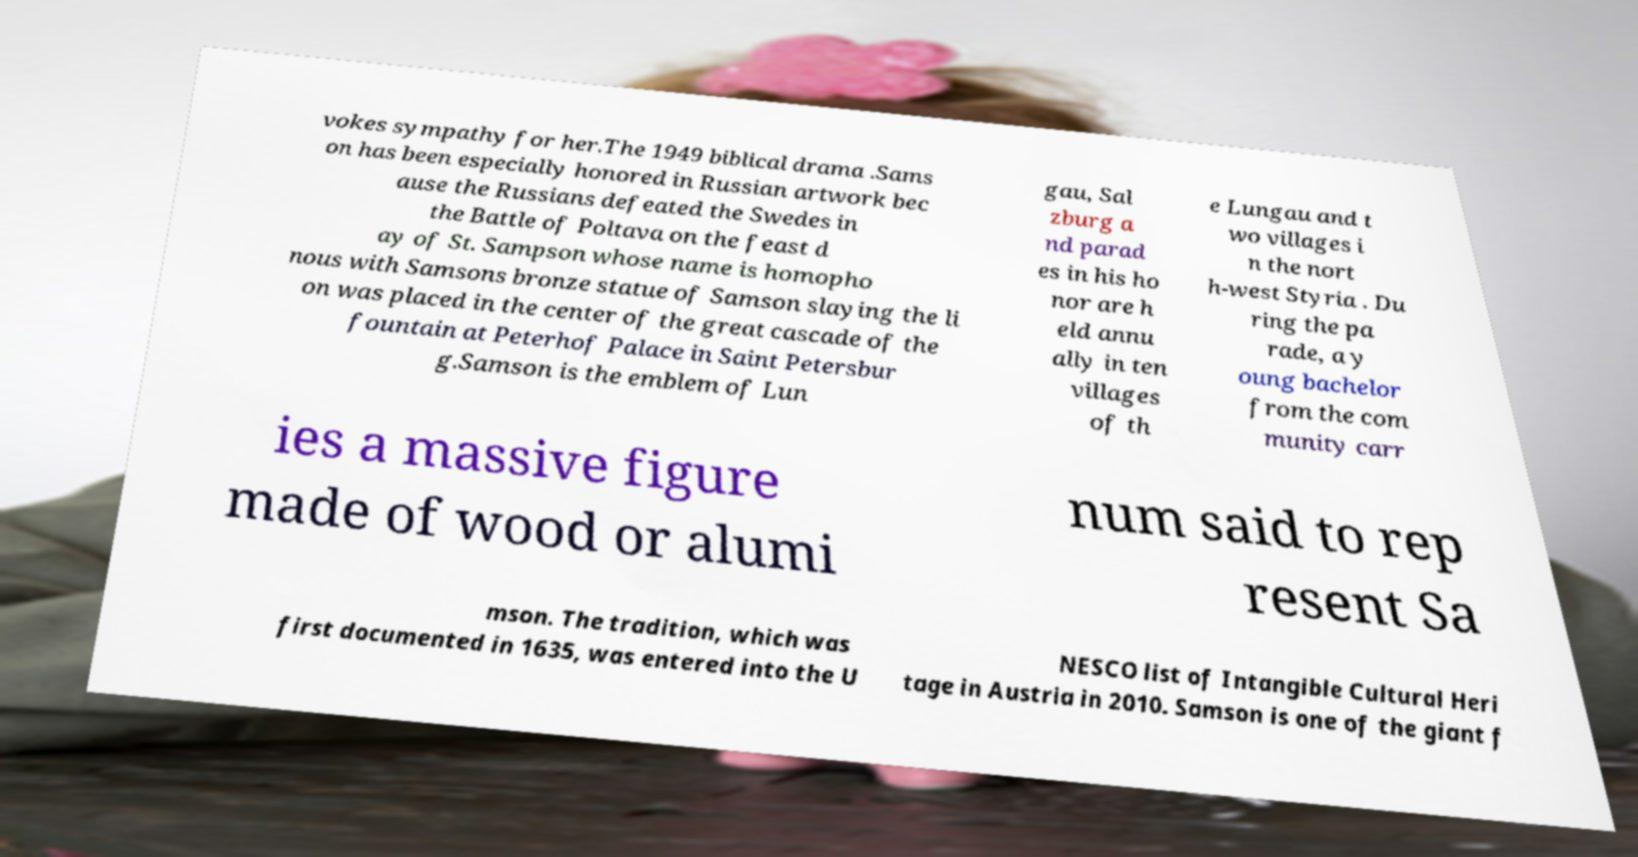What messages or text are displayed in this image? I need them in a readable, typed format. vokes sympathy for her.The 1949 biblical drama .Sams on has been especially honored in Russian artwork bec ause the Russians defeated the Swedes in the Battle of Poltava on the feast d ay of St. Sampson whose name is homopho nous with Samsons bronze statue of Samson slaying the li on was placed in the center of the great cascade of the fountain at Peterhof Palace in Saint Petersbur g.Samson is the emblem of Lun gau, Sal zburg a nd parad es in his ho nor are h eld annu ally in ten villages of th e Lungau and t wo villages i n the nort h-west Styria . Du ring the pa rade, a y oung bachelor from the com munity carr ies a massive figure made of wood or alumi num said to rep resent Sa mson. The tradition, which was first documented in 1635, was entered into the U NESCO list of Intangible Cultural Heri tage in Austria in 2010. Samson is one of the giant f 